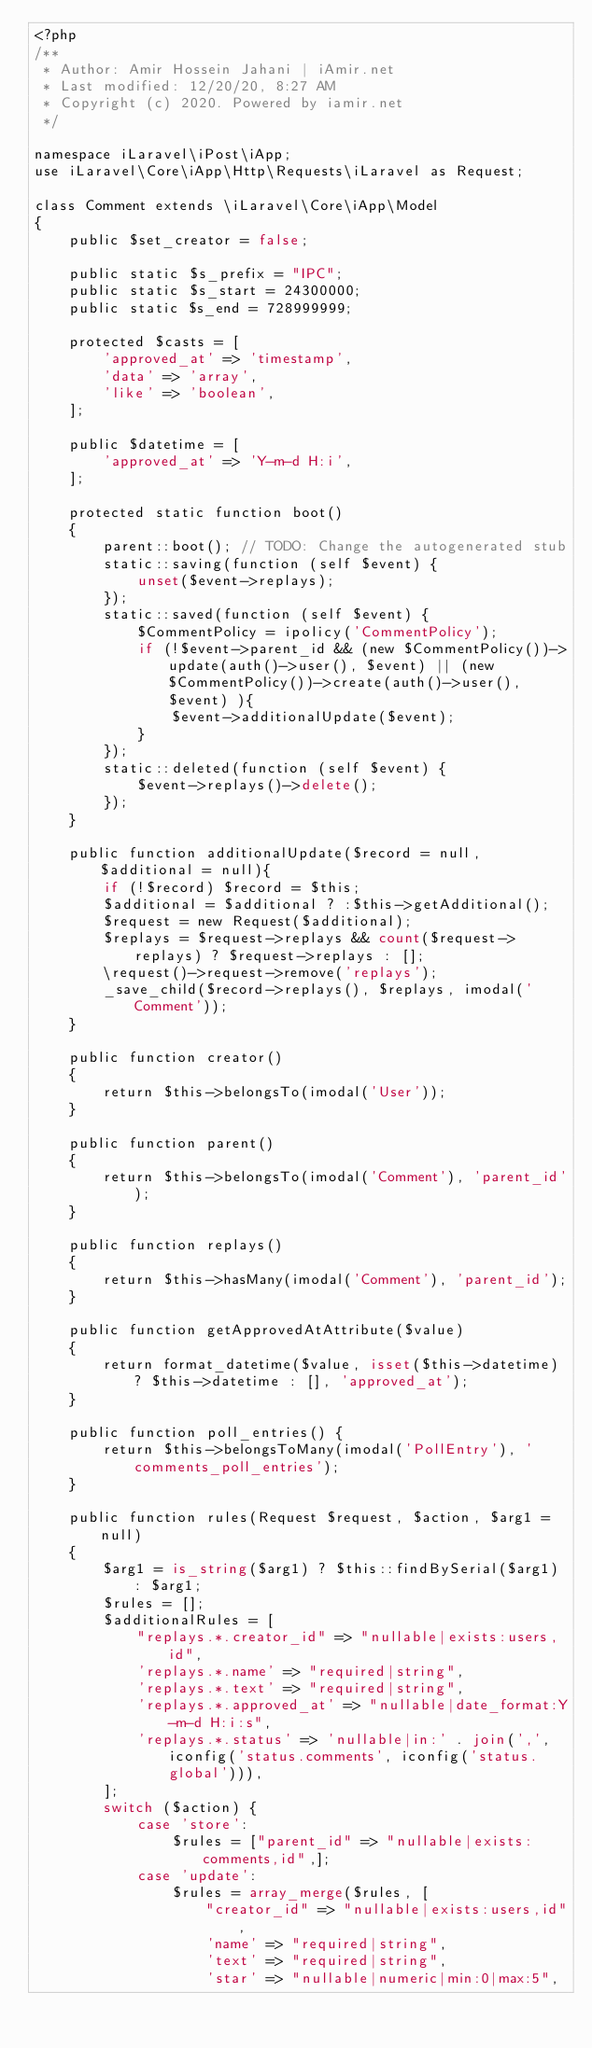Convert code to text. <code><loc_0><loc_0><loc_500><loc_500><_PHP_><?php
/**
 * Author: Amir Hossein Jahani | iAmir.net
 * Last modified: 12/20/20, 8:27 AM
 * Copyright (c) 2020. Powered by iamir.net
 */

namespace iLaravel\iPost\iApp;
use iLaravel\Core\iApp\Http\Requests\iLaravel as Request;

class Comment extends \iLaravel\Core\iApp\Model
{
    public $set_creator = false;

    public static $s_prefix = "IPC";
    public static $s_start = 24300000;
    public static $s_end = 728999999;

    protected $casts = [
        'approved_at' => 'timestamp',
        'data' => 'array',
        'like' => 'boolean',
    ];

    public $datetime = [
        'approved_at' => 'Y-m-d H:i',
    ];

    protected static function boot()
    {
        parent::boot(); // TODO: Change the autogenerated stub
        static::saving(function (self $event) {
            unset($event->replays);
        });
        static::saved(function (self $event) {
            $CommentPolicy = ipolicy('CommentPolicy');
            if (!$event->parent_id && (new $CommentPolicy())->update(auth()->user(), $event) || (new $CommentPolicy())->create(auth()->user(), $event) ){
                $event->additionalUpdate($event);
            }
        });
        static::deleted(function (self $event) {
            $event->replays()->delete();
        });
    }

    public function additionalUpdate($record = null, $additional = null){
        if (!$record) $record = $this;
        $additional = $additional ? :$this->getAdditional();
        $request = new Request($additional);
        $replays = $request->replays && count($request->replays) ? $request->replays : [];
        \request()->request->remove('replays');
        _save_child($record->replays(), $replays, imodal('Comment'));
    }

    public function creator()
    {
        return $this->belongsTo(imodal('User'));
    }

    public function parent()
    {
        return $this->belongsTo(imodal('Comment'), 'parent_id');
    }

    public function replays()
    {
        return $this->hasMany(imodal('Comment'), 'parent_id');
    }

    public function getApprovedAtAttribute($value)
    {
        return format_datetime($value, isset($this->datetime) ? $this->datetime : [], 'approved_at');
    }

    public function poll_entries() {
        return $this->belongsToMany(imodal('PollEntry'), 'comments_poll_entries');
    }

    public function rules(Request $request, $action, $arg1 = null)
    {
        $arg1 = is_string($arg1) ? $this::findBySerial($arg1) : $arg1;
        $rules = [];
        $additionalRules = [
            "replays.*.creator_id" => "nullable|exists:users,id",
            'replays.*.name' => "required|string",
            'replays.*.text' => "required|string",
            'replays.*.approved_at' => "nullable|date_format:Y-m-d H:i:s",
            'replays.*.status' => 'nullable|in:' . join(',', iconfig('status.comments', iconfig('status.global'))),
        ];
        switch ($action) {
            case 'store':
                $rules = ["parent_id" => "nullable|exists:comments,id",];
            case 'update':
                $rules = array_merge($rules, [
                    "creator_id" => "nullable|exists:users,id",
                    'name' => "required|string",
                    'text' => "required|string",
                    'star' => "nullable|numeric|min:0|max:5",</code> 